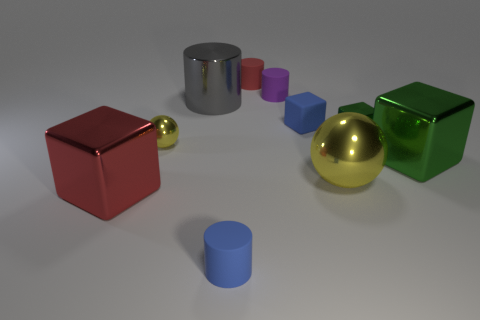Subtract all yellow cylinders. How many green cubes are left? 2 Subtract all matte cylinders. How many cylinders are left? 1 Subtract 1 cubes. How many cubes are left? 3 Subtract all red cubes. How many cubes are left? 3 Add 7 large balls. How many large balls are left? 8 Add 9 tiny cyan rubber spheres. How many tiny cyan rubber spheres exist? 9 Subtract 0 red balls. How many objects are left? 10 Subtract all blocks. How many objects are left? 6 Subtract all red cylinders. Subtract all brown blocks. How many cylinders are left? 3 Subtract all yellow metallic cubes. Subtract all big gray metallic cylinders. How many objects are left? 9 